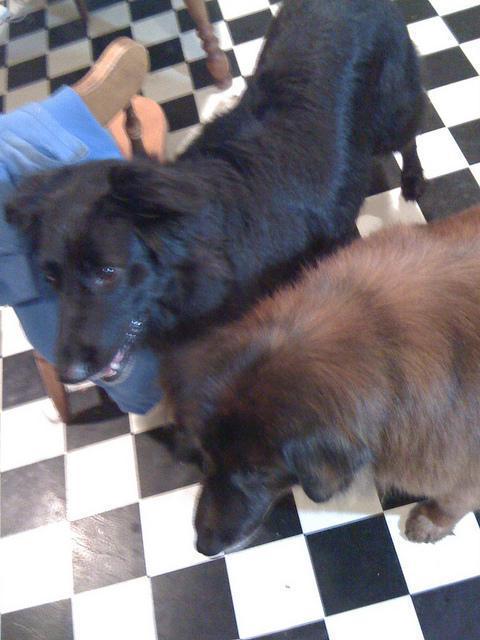How many dogs can you see?
Give a very brief answer. 2. 